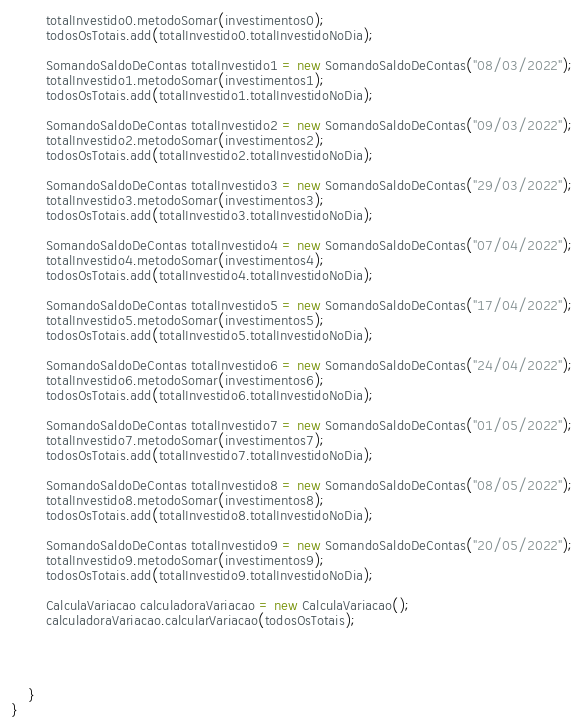<code> <loc_0><loc_0><loc_500><loc_500><_Java_>        totalInvestido0.metodoSomar(investimentos0);
        todosOsTotais.add(totalInvestido0.totalInvestidoNoDia);

        SomandoSaldoDeContas totalInvestido1 = new SomandoSaldoDeContas("08/03/2022");
        totalInvestido1.metodoSomar(investimentos1);
        todosOsTotais.add(totalInvestido1.totalInvestidoNoDia);

        SomandoSaldoDeContas totalInvestido2 = new SomandoSaldoDeContas("09/03/2022");
        totalInvestido2.metodoSomar(investimentos2);
        todosOsTotais.add(totalInvestido2.totalInvestidoNoDia);

        SomandoSaldoDeContas totalInvestido3 = new SomandoSaldoDeContas("29/03/2022");
        totalInvestido3.metodoSomar(investimentos3);
        todosOsTotais.add(totalInvestido3.totalInvestidoNoDia);

        SomandoSaldoDeContas totalInvestido4 = new SomandoSaldoDeContas("07/04/2022");
        totalInvestido4.metodoSomar(investimentos4);
        todosOsTotais.add(totalInvestido4.totalInvestidoNoDia);

        SomandoSaldoDeContas totalInvestido5 = new SomandoSaldoDeContas("17/04/2022");
        totalInvestido5.metodoSomar(investimentos5);
        todosOsTotais.add(totalInvestido5.totalInvestidoNoDia);

        SomandoSaldoDeContas totalInvestido6 = new SomandoSaldoDeContas("24/04/2022");
        totalInvestido6.metodoSomar(investimentos6);
        todosOsTotais.add(totalInvestido6.totalInvestidoNoDia);

        SomandoSaldoDeContas totalInvestido7 = new SomandoSaldoDeContas("01/05/2022");
        totalInvestido7.metodoSomar(investimentos7);
        todosOsTotais.add(totalInvestido7.totalInvestidoNoDia);

        SomandoSaldoDeContas totalInvestido8 = new SomandoSaldoDeContas("08/05/2022");
        totalInvestido8.metodoSomar(investimentos8);
        todosOsTotais.add(totalInvestido8.totalInvestidoNoDia);

        SomandoSaldoDeContas totalInvestido9 = new SomandoSaldoDeContas("20/05/2022");
        totalInvestido9.metodoSomar(investimentos9);
        todosOsTotais.add(totalInvestido9.totalInvestidoNoDia);

        CalculaVariacao calculadoraVariacao = new CalculaVariacao();
        calculadoraVariacao.calcularVariacao(todosOsTotais);




    }
}</code> 